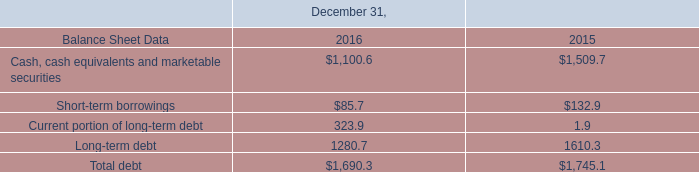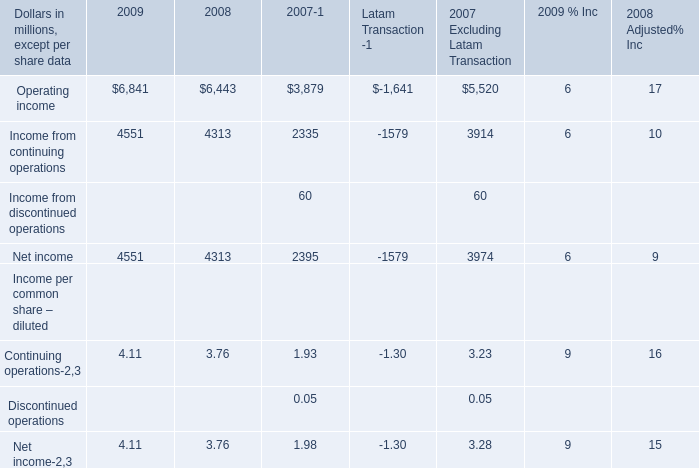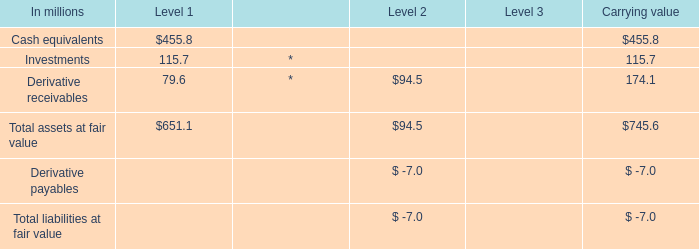How many kinds of elements in 2009 are greater than those in the previous year? 
Answer: 3. 